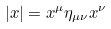Convert formula to latex. <formula><loc_0><loc_0><loc_500><loc_500>| { x } | = x ^ { \mu } \eta _ { \mu \nu } x ^ { \nu }</formula> 